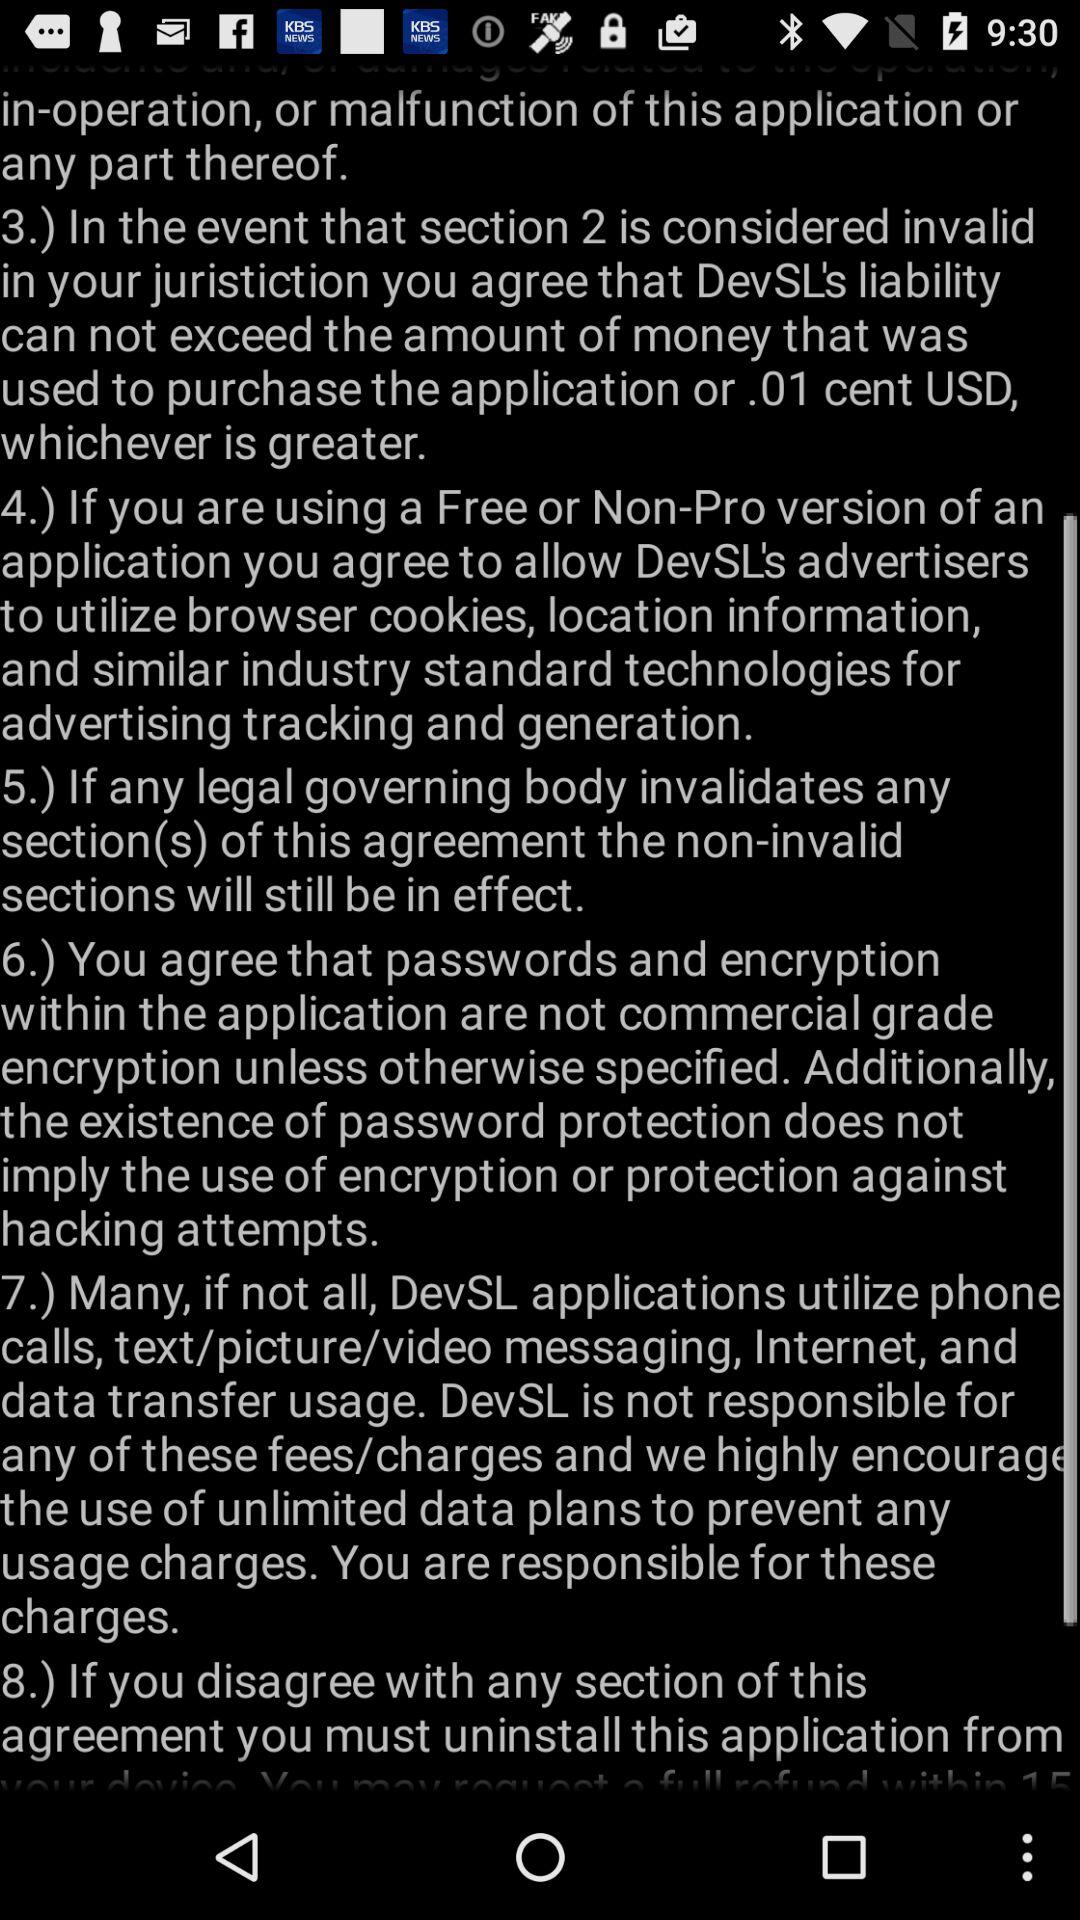How many sections are there in the EULA?
Answer the question using a single word or phrase. 8 